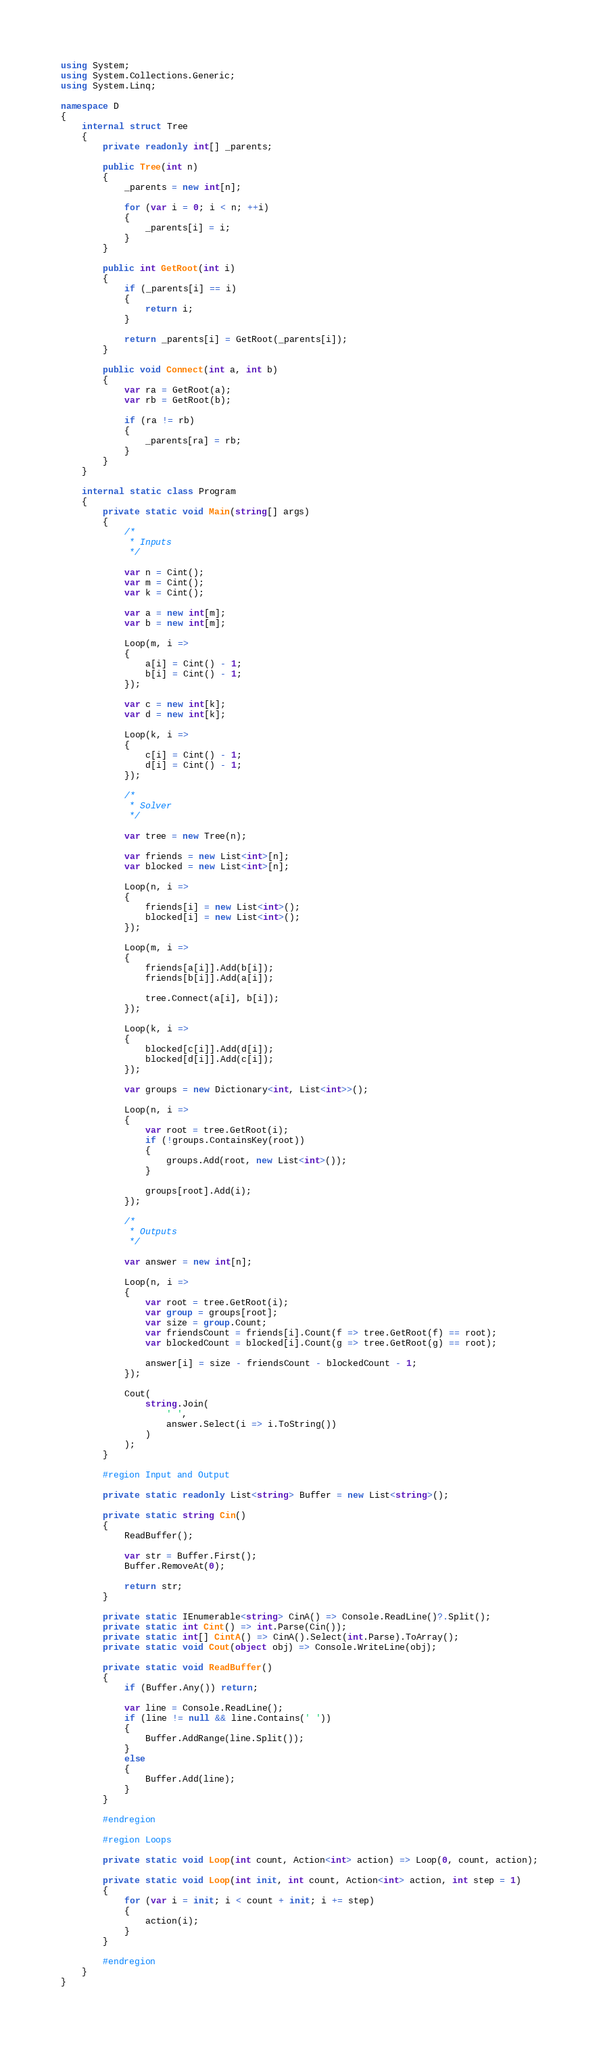<code> <loc_0><loc_0><loc_500><loc_500><_C#_>using System;
using System.Collections.Generic;
using System.Linq;

namespace D
{
    internal struct Tree
    {
        private readonly int[] _parents;

        public Tree(int n)
        {
            _parents = new int[n];

            for (var i = 0; i < n; ++i)
            {
                _parents[i] = i;
            }
        }

        public int GetRoot(int i)
        {
            if (_parents[i] == i)
            {
                return i;
            }

            return _parents[i] = GetRoot(_parents[i]);
        }

        public void Connect(int a, int b)
        {
            var ra = GetRoot(a);
            var rb = GetRoot(b);

            if (ra != rb)
            {
                _parents[ra] = rb;
            }
        }
    }
    
    internal static class Program
    {
        private static void Main(string[] args)
        {
            /*
             * Inputs
             */
            
            var n = Cint();
            var m = Cint();
            var k = Cint();

            var a = new int[m];
            var b = new int[m];

            Loop(m, i =>
            {
                a[i] = Cint() - 1;
                b[i] = Cint() - 1;
            });

            var c = new int[k];
            var d = new int[k];
            
            Loop(k, i =>
            {
                c[i] = Cint() - 1;
                d[i] = Cint() - 1;
            });
            
            /*
             * Solver
             */

            var tree = new Tree(n);

            var friends = new List<int>[n];
            var blocked = new List<int>[n];
            
            Loop(n, i =>
            {
                friends[i] = new List<int>();
                blocked[i] = new List<int>();
            });
            
            Loop(m, i =>
            {
                friends[a[i]].Add(b[i]);
                friends[b[i]].Add(a[i]);
                
                tree.Connect(a[i], b[i]);
            });

            Loop(k, i =>
            {
                blocked[c[i]].Add(d[i]);
                blocked[d[i]].Add(c[i]);
            });
            
            var groups = new Dictionary<int, List<int>>();

            Loop(n, i =>
            {
                var root = tree.GetRoot(i);
                if (!groups.ContainsKey(root))
                {
                    groups.Add(root, new List<int>());
                }

                groups[root].Add(i);
            });

            /*
             * Outputs
             */

            var answer = new int[n];
            
            Loop(n, i =>
            {
                var root = tree.GetRoot(i);
                var group = groups[root];
                var size = group.Count;
                var friendsCount = friends[i].Count(f => tree.GetRoot(f) == root);
                var blockedCount = blocked[i].Count(g => tree.GetRoot(g) == root);

                answer[i] = size - friendsCount - blockedCount - 1;
            });
            
            Cout(
                string.Join(
                    ' ',
                    answer.Select(i => i.ToString())
                )
            );
        }

        #region Input and Output

        private static readonly List<string> Buffer = new List<string>();

        private static string Cin()
        {
            ReadBuffer();

            var str = Buffer.First();
            Buffer.RemoveAt(0);

            return str;
        }

        private static IEnumerable<string> CinA() => Console.ReadLine()?.Split();
        private static int Cint() => int.Parse(Cin());
        private static int[] CintA() => CinA().Select(int.Parse).ToArray();
        private static void Cout(object obj) => Console.WriteLine(obj);

        private static void ReadBuffer()
        {
            if (Buffer.Any()) return;

            var line = Console.ReadLine();
            if (line != null && line.Contains(' '))
            {
                Buffer.AddRange(line.Split());
            }
            else
            {
                Buffer.Add(line);
            }
        }

        #endregion

        #region Loops

        private static void Loop(int count, Action<int> action) => Loop(0, count, action);

        private static void Loop(int init, int count, Action<int> action, int step = 1)
        {
            for (var i = init; i < count + init; i += step)
            {
                action(i);
            }
        }

        #endregion
    }
}
</code> 